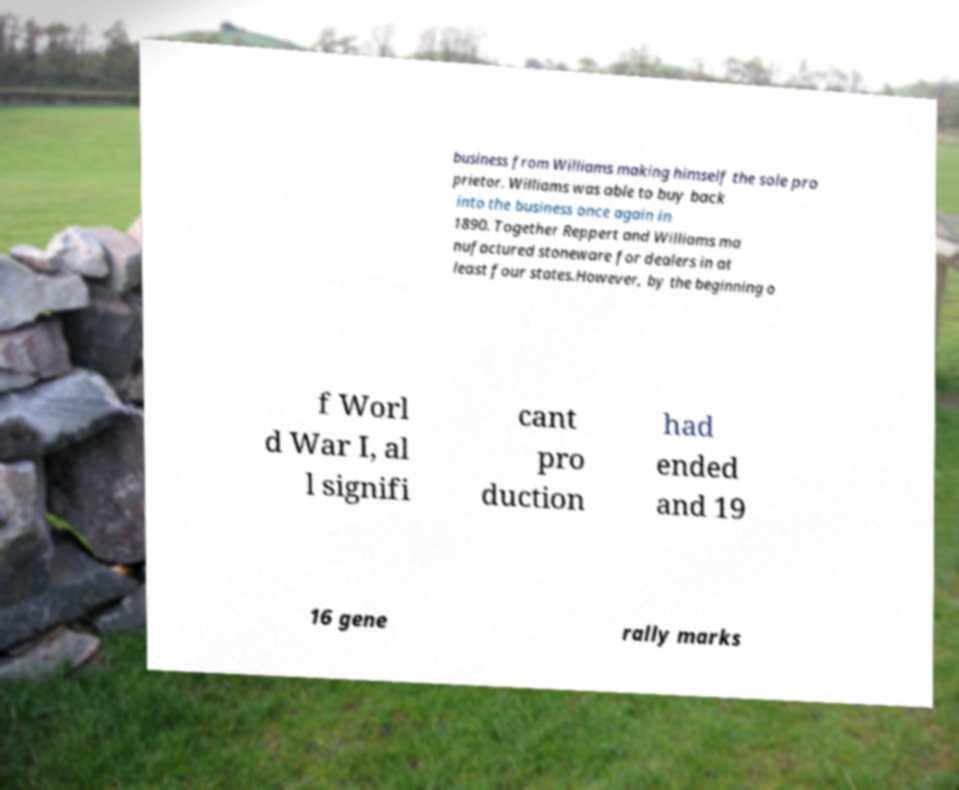For documentation purposes, I need the text within this image transcribed. Could you provide that? business from Williams making himself the sole pro prietor. Williams was able to buy back into the business once again in 1890. Together Reppert and Williams ma nufactured stoneware for dealers in at least four states.However, by the beginning o f Worl d War I, al l signifi cant pro duction had ended and 19 16 gene rally marks 